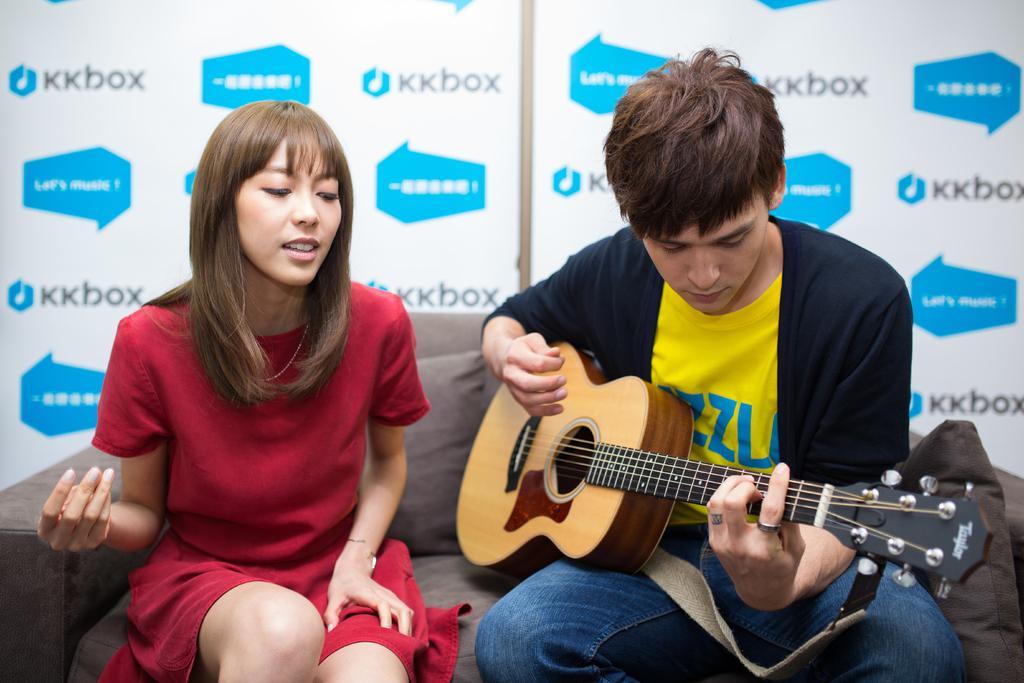Could you give a brief overview of what you see in this image? This woman and this man are sitting on a couch with pillow. This woman wore red dress. This man wore jacket and playing a guitar. 